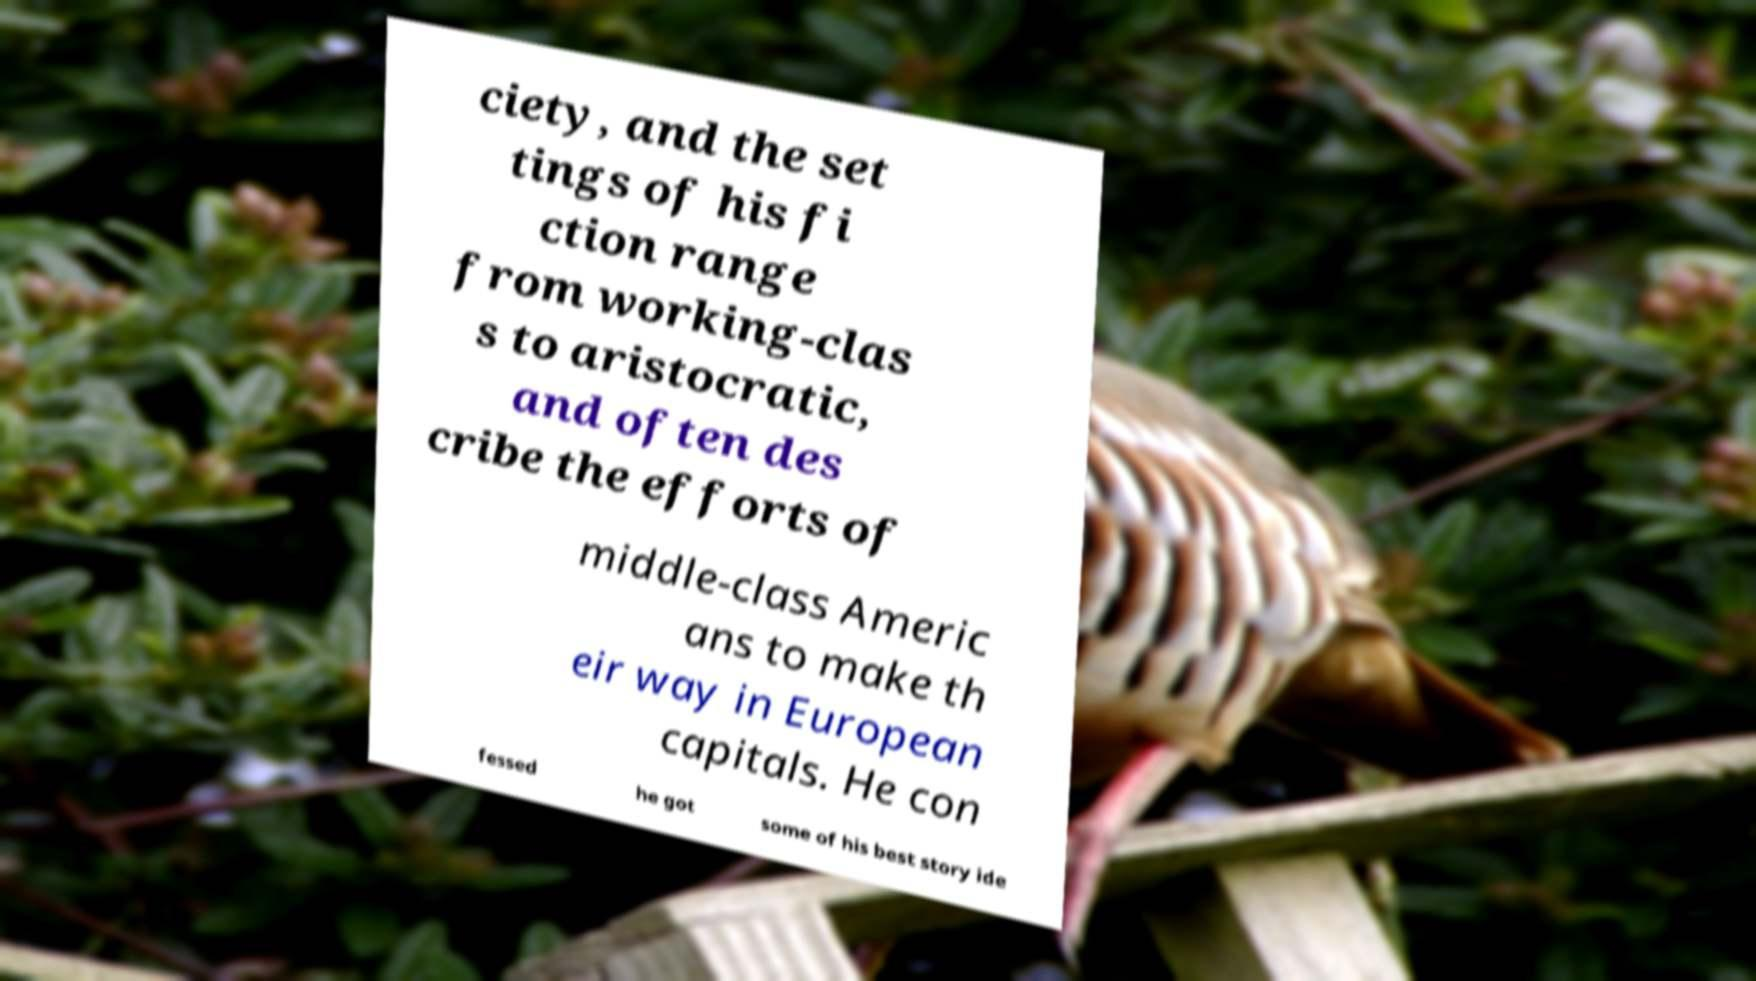Could you assist in decoding the text presented in this image and type it out clearly? ciety, and the set tings of his fi ction range from working-clas s to aristocratic, and often des cribe the efforts of middle-class Americ ans to make th eir way in European capitals. He con fessed he got some of his best story ide 